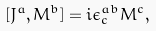<formula> <loc_0><loc_0><loc_500><loc_500>[ J ^ { a } , M ^ { b } ] = i \epsilon ^ { a b } _ { c } M ^ { c } ,</formula> 